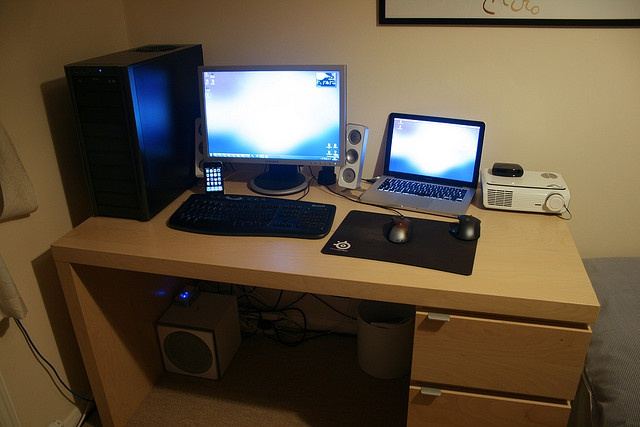Describe the objects in this image and their specific colors. I can see tv in black, white, gray, and lightblue tones, laptop in black, white, gray, and navy tones, keyboard in black, navy, and maroon tones, keyboard in black, navy, gray, and blue tones, and cell phone in black, white, navy, and lightblue tones in this image. 